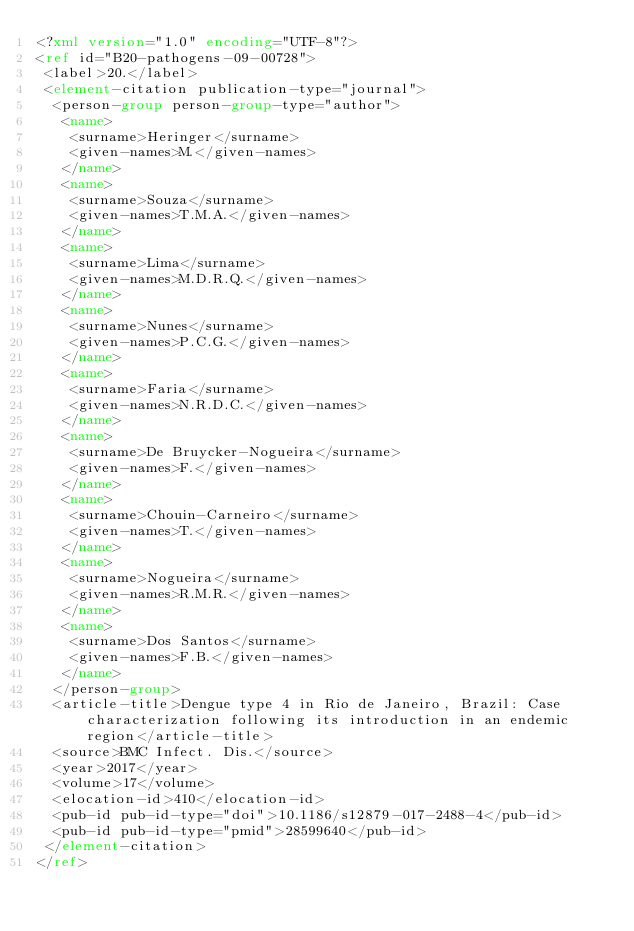<code> <loc_0><loc_0><loc_500><loc_500><_XML_><?xml version="1.0" encoding="UTF-8"?>
<ref id="B20-pathogens-09-00728">
 <label>20.</label>
 <element-citation publication-type="journal">
  <person-group person-group-type="author">
   <name>
    <surname>Heringer</surname>
    <given-names>M.</given-names>
   </name>
   <name>
    <surname>Souza</surname>
    <given-names>T.M.A.</given-names>
   </name>
   <name>
    <surname>Lima</surname>
    <given-names>M.D.R.Q.</given-names>
   </name>
   <name>
    <surname>Nunes</surname>
    <given-names>P.C.G.</given-names>
   </name>
   <name>
    <surname>Faria</surname>
    <given-names>N.R.D.C.</given-names>
   </name>
   <name>
    <surname>De Bruycker-Nogueira</surname>
    <given-names>F.</given-names>
   </name>
   <name>
    <surname>Chouin-Carneiro</surname>
    <given-names>T.</given-names>
   </name>
   <name>
    <surname>Nogueira</surname>
    <given-names>R.M.R.</given-names>
   </name>
   <name>
    <surname>Dos Santos</surname>
    <given-names>F.B.</given-names>
   </name>
  </person-group>
  <article-title>Dengue type 4 in Rio de Janeiro, Brazil: Case characterization following its introduction in an endemic region</article-title>
  <source>BMC Infect. Dis.</source>
  <year>2017</year>
  <volume>17</volume>
  <elocation-id>410</elocation-id>
  <pub-id pub-id-type="doi">10.1186/s12879-017-2488-4</pub-id>
  <pub-id pub-id-type="pmid">28599640</pub-id>
 </element-citation>
</ref>
</code> 